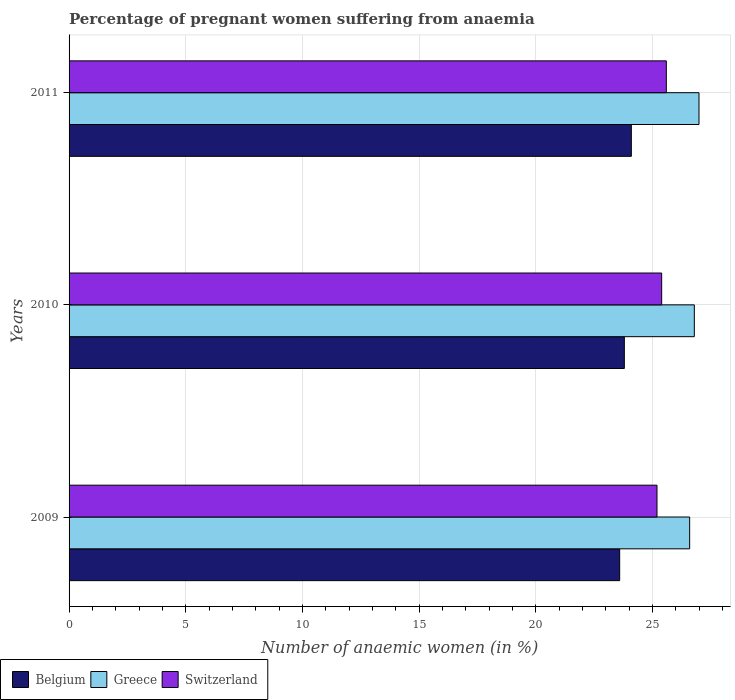How many different coloured bars are there?
Offer a very short reply. 3. How many groups of bars are there?
Offer a very short reply. 3. Are the number of bars per tick equal to the number of legend labels?
Make the answer very short. Yes. Are the number of bars on each tick of the Y-axis equal?
Provide a short and direct response. Yes. How many bars are there on the 1st tick from the bottom?
Your answer should be very brief. 3. What is the label of the 3rd group of bars from the top?
Make the answer very short. 2009. Across all years, what is the minimum number of anaemic women in Switzerland?
Give a very brief answer. 25.2. What is the total number of anaemic women in Greece in the graph?
Ensure brevity in your answer.  80.4. What is the difference between the number of anaemic women in Switzerland in 2009 and that in 2011?
Ensure brevity in your answer.  -0.4. What is the difference between the number of anaemic women in Switzerland in 2009 and the number of anaemic women in Belgium in 2011?
Offer a terse response. 1.1. What is the average number of anaemic women in Greece per year?
Provide a succinct answer. 26.8. In the year 2011, what is the difference between the number of anaemic women in Greece and number of anaemic women in Belgium?
Your answer should be very brief. 2.9. What is the ratio of the number of anaemic women in Greece in 2010 to that in 2011?
Your answer should be compact. 0.99. Is the number of anaemic women in Greece in 2009 less than that in 2010?
Keep it short and to the point. Yes. What is the difference between the highest and the second highest number of anaemic women in Greece?
Ensure brevity in your answer.  0.2. What is the difference between the highest and the lowest number of anaemic women in Belgium?
Provide a short and direct response. 0.5. In how many years, is the number of anaemic women in Greece greater than the average number of anaemic women in Greece taken over all years?
Ensure brevity in your answer.  1. Is the sum of the number of anaemic women in Belgium in 2009 and 2010 greater than the maximum number of anaemic women in Greece across all years?
Give a very brief answer. Yes. What does the 3rd bar from the bottom in 2010 represents?
Ensure brevity in your answer.  Switzerland. Is it the case that in every year, the sum of the number of anaemic women in Greece and number of anaemic women in Belgium is greater than the number of anaemic women in Switzerland?
Your answer should be very brief. Yes. Are all the bars in the graph horizontal?
Make the answer very short. Yes. What is the difference between two consecutive major ticks on the X-axis?
Your answer should be very brief. 5. Does the graph contain any zero values?
Provide a short and direct response. No. Does the graph contain grids?
Give a very brief answer. Yes. How many legend labels are there?
Offer a terse response. 3. How are the legend labels stacked?
Offer a terse response. Horizontal. What is the title of the graph?
Your response must be concise. Percentage of pregnant women suffering from anaemia. What is the label or title of the X-axis?
Your response must be concise. Number of anaemic women (in %). What is the label or title of the Y-axis?
Your answer should be very brief. Years. What is the Number of anaemic women (in %) in Belgium in 2009?
Give a very brief answer. 23.6. What is the Number of anaemic women (in %) in Greece in 2009?
Keep it short and to the point. 26.6. What is the Number of anaemic women (in %) in Switzerland in 2009?
Keep it short and to the point. 25.2. What is the Number of anaemic women (in %) of Belgium in 2010?
Provide a short and direct response. 23.8. What is the Number of anaemic women (in %) in Greece in 2010?
Your response must be concise. 26.8. What is the Number of anaemic women (in %) of Switzerland in 2010?
Offer a very short reply. 25.4. What is the Number of anaemic women (in %) in Belgium in 2011?
Your answer should be very brief. 24.1. What is the Number of anaemic women (in %) in Greece in 2011?
Offer a very short reply. 27. What is the Number of anaemic women (in %) in Switzerland in 2011?
Your response must be concise. 25.6. Across all years, what is the maximum Number of anaemic women (in %) in Belgium?
Make the answer very short. 24.1. Across all years, what is the maximum Number of anaemic women (in %) of Greece?
Make the answer very short. 27. Across all years, what is the maximum Number of anaemic women (in %) of Switzerland?
Your answer should be compact. 25.6. Across all years, what is the minimum Number of anaemic women (in %) of Belgium?
Offer a very short reply. 23.6. Across all years, what is the minimum Number of anaemic women (in %) in Greece?
Offer a terse response. 26.6. Across all years, what is the minimum Number of anaemic women (in %) in Switzerland?
Your response must be concise. 25.2. What is the total Number of anaemic women (in %) of Belgium in the graph?
Ensure brevity in your answer.  71.5. What is the total Number of anaemic women (in %) of Greece in the graph?
Your answer should be very brief. 80.4. What is the total Number of anaemic women (in %) in Switzerland in the graph?
Your response must be concise. 76.2. What is the difference between the Number of anaemic women (in %) of Belgium in 2009 and that in 2010?
Your answer should be compact. -0.2. What is the difference between the Number of anaemic women (in %) in Belgium in 2009 and that in 2011?
Keep it short and to the point. -0.5. What is the difference between the Number of anaemic women (in %) of Greece in 2009 and that in 2011?
Keep it short and to the point. -0.4. What is the difference between the Number of anaemic women (in %) of Switzerland in 2009 and that in 2011?
Offer a very short reply. -0.4. What is the difference between the Number of anaemic women (in %) of Greece in 2010 and that in 2011?
Ensure brevity in your answer.  -0.2. What is the difference between the Number of anaemic women (in %) of Belgium in 2009 and the Number of anaemic women (in %) of Greece in 2010?
Provide a short and direct response. -3.2. What is the difference between the Number of anaemic women (in %) in Greece in 2009 and the Number of anaemic women (in %) in Switzerland in 2010?
Offer a terse response. 1.2. What is the difference between the Number of anaemic women (in %) in Belgium in 2009 and the Number of anaemic women (in %) in Switzerland in 2011?
Ensure brevity in your answer.  -2. What is the difference between the Number of anaemic women (in %) in Greece in 2009 and the Number of anaemic women (in %) in Switzerland in 2011?
Your response must be concise. 1. What is the difference between the Number of anaemic women (in %) of Belgium in 2010 and the Number of anaemic women (in %) of Greece in 2011?
Provide a succinct answer. -3.2. What is the difference between the Number of anaemic women (in %) in Belgium in 2010 and the Number of anaemic women (in %) in Switzerland in 2011?
Your answer should be compact. -1.8. What is the average Number of anaemic women (in %) in Belgium per year?
Your response must be concise. 23.83. What is the average Number of anaemic women (in %) in Greece per year?
Give a very brief answer. 26.8. What is the average Number of anaemic women (in %) of Switzerland per year?
Give a very brief answer. 25.4. In the year 2009, what is the difference between the Number of anaemic women (in %) in Belgium and Number of anaemic women (in %) in Switzerland?
Make the answer very short. -1.6. In the year 2009, what is the difference between the Number of anaemic women (in %) of Greece and Number of anaemic women (in %) of Switzerland?
Your answer should be compact. 1.4. In the year 2010, what is the difference between the Number of anaemic women (in %) in Greece and Number of anaemic women (in %) in Switzerland?
Give a very brief answer. 1.4. In the year 2011, what is the difference between the Number of anaemic women (in %) of Belgium and Number of anaemic women (in %) of Greece?
Your answer should be very brief. -2.9. In the year 2011, what is the difference between the Number of anaemic women (in %) in Greece and Number of anaemic women (in %) in Switzerland?
Give a very brief answer. 1.4. What is the ratio of the Number of anaemic women (in %) of Belgium in 2009 to that in 2010?
Keep it short and to the point. 0.99. What is the ratio of the Number of anaemic women (in %) of Switzerland in 2009 to that in 2010?
Provide a short and direct response. 0.99. What is the ratio of the Number of anaemic women (in %) of Belgium in 2009 to that in 2011?
Your response must be concise. 0.98. What is the ratio of the Number of anaemic women (in %) of Greece in 2009 to that in 2011?
Your answer should be compact. 0.99. What is the ratio of the Number of anaemic women (in %) in Switzerland in 2009 to that in 2011?
Offer a very short reply. 0.98. What is the ratio of the Number of anaemic women (in %) of Belgium in 2010 to that in 2011?
Your answer should be compact. 0.99. What is the ratio of the Number of anaemic women (in %) in Greece in 2010 to that in 2011?
Give a very brief answer. 0.99. What is the difference between the highest and the second highest Number of anaemic women (in %) in Belgium?
Offer a very short reply. 0.3. What is the difference between the highest and the second highest Number of anaemic women (in %) in Switzerland?
Make the answer very short. 0.2. What is the difference between the highest and the lowest Number of anaemic women (in %) of Greece?
Your answer should be very brief. 0.4. 